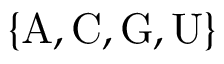<formula> <loc_0><loc_0><loc_500><loc_500>\{ A , C , G , U \}</formula> 